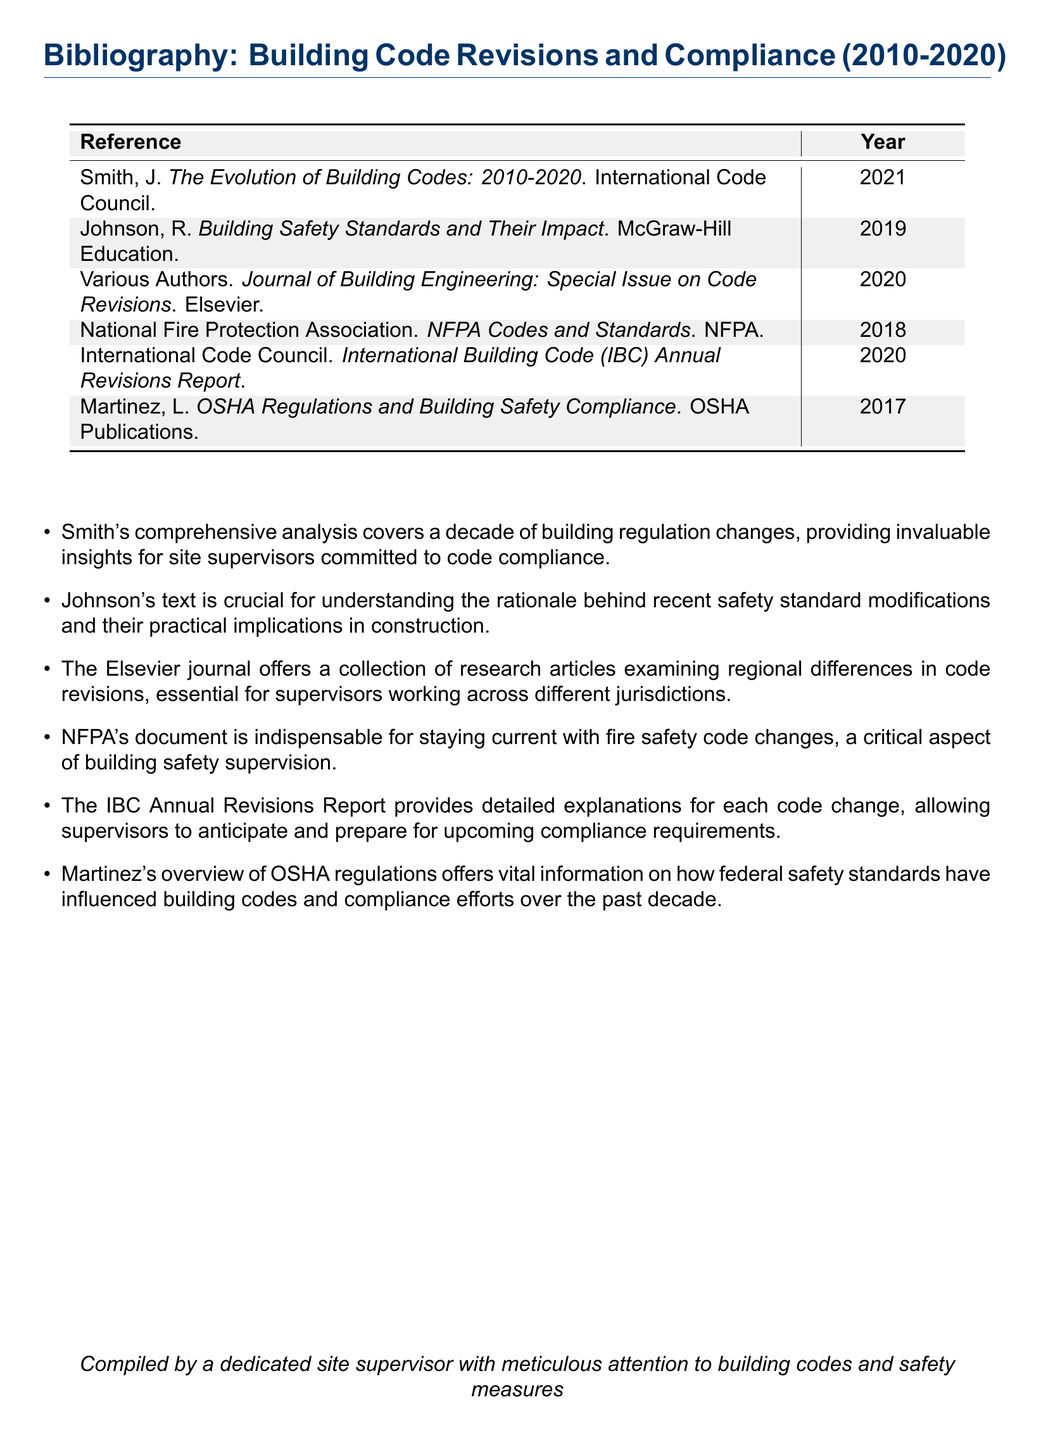What is the title of the 2020 special issue journal? The title refers to a specific scholarly publication and is noted in the bibliography as "Journal of Building Engineering: Special Issue on Code Revisions".
Answer: Journal of Building Engineering: Special Issue on Code Revisions Which organization published the document on NFPA Codes and Standards? The publisher for the NFPA Codes and Standards is given as the National Fire Protection Association in the bibliography.
Answer: NFPA In what year was the document by Martinez published? The specific publication year for Martinez's work is clearly indicated next to the reference.
Answer: 2017 What is the main focus of Johnson's publication? The description next to Johnson's reference highlights the focus of the book on understanding safety standard modifications.
Answer: Safety standards How many references listed are published after 2018? By reviewing the bibliography, you can count the references that are dated after 2018.
Answer: 3 Which year did the International Code Council report provide its findings? The year associated with the International Building Code Annual Revisions Report is explicitly noted in the bibliography.
Answer: 2020 What significant theme does Smith's work cover? The overview of Smith’s publication emphasizes its analysis of changes in building regulations over a specified time period.
Answer: Building regulation changes What type of document is this bibliography categorized as? The structure and content of the document define it specifically as a bibliographical list.
Answer: Bibliography 